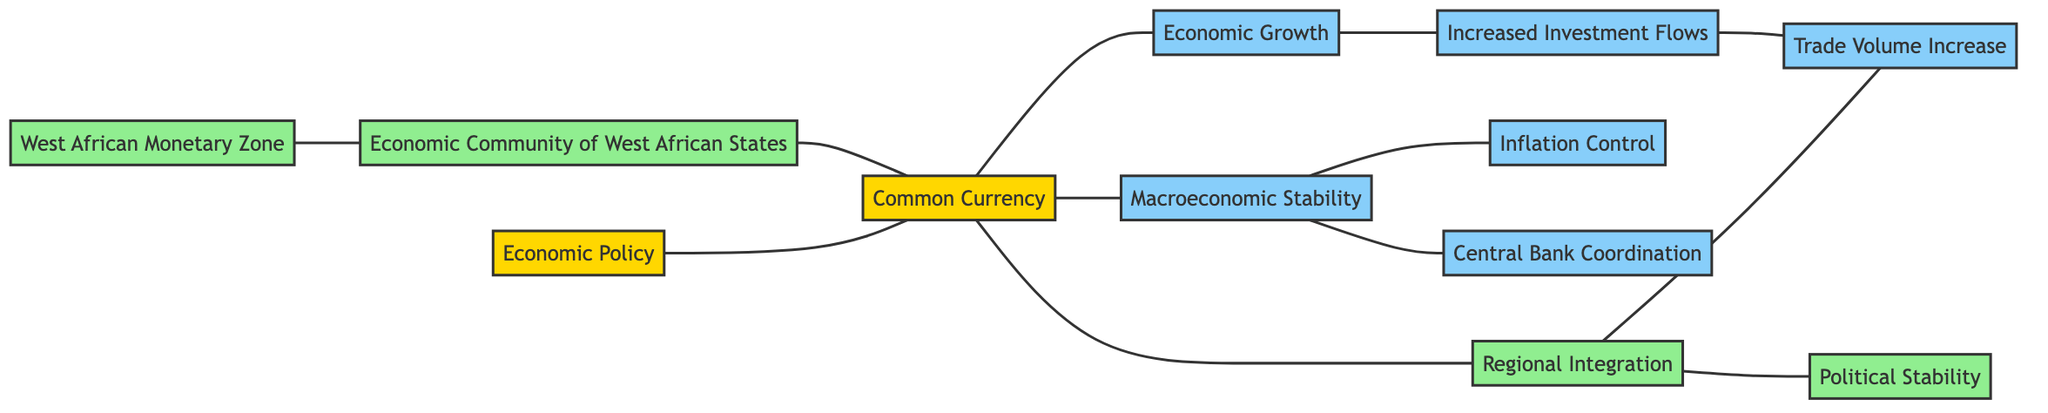What are the total number of nodes in the diagram? The diagram contains a total of 12 nodes, which are Economic Policy, Common Currency, Regional Integration, Trade Volume Increase, West African Monetary Zone, Economic Community of West African States, Macroeconomic Stability, Inflation Control, Central Bank Coordination, Economic Growth, Increased Investment Flows, and Political Stability.
Answer: 12 Which node connects Economic Policy and Common Currency? The edge directly connects Economic Policy to Common Currency, indicating a relationship where Economic Policy influences the adoption of a Common Currency.
Answer: Common Currency What are the two nodes connected to Macroeconomic Stability? Macroeconomic Stability connects to Inflation Control and Central Bank Coordination. This suggests that achieving stability entails controlling inflation and coordinating central banks.
Answer: Inflation Control and Central Bank Coordination How many direct connections does Regional Integration have? Regional Integration has three direct edges: it connects to Common Currency, Trade Volume Increase, and Political Stability. This indicates various influences and outcomes associated with Regional Integration.
Answer: 3 What is the relationship between Economic Growth and Increased Investment Flows? Economic Growth influences Increased Investment Flows, indicating that as the economy grows, it tends to attract more investment, leading to increased flow of funds.
Answer: Economic Growth influences Increased Investment Flows Which two nodes are linked by West African Monetary Zone? West African Monetary Zone is directly linked to Economic Community of West African States, showing that these two entities may work together concerning economic matters.
Answer: Economic Community of West African States What is the output when Common Currency is adopted regarding Trade Volume Increase? The adoption of a Common Currency leads to an increase in Trade Volume. This connection highlights how currency union may promote greater trade among regions.
Answer: Trade Volume Increase What is the role of Inflation Control in respect to Macroeconomic Stability? Inflation Control is a part of achieving Macroeconomic Stability, as controlling inflation is essential to stabilize an economy's overall performance.
Answer: Inflation Control is part of Macroeconomic Stability How many edges are in the diagram? The diagram contains 11 edges, which represent the connections between the various nodes, demonstrating the relationships and influence among them.
Answer: 11 Which nodes are connected through Trade Volume Increase? Trade Volume Increase connects to Regional Integration and Increased Investment Flows, indicating that trade volume growth is related to both integration and investment flows.
Answer: Regional Integration and Increased Investment Flows 